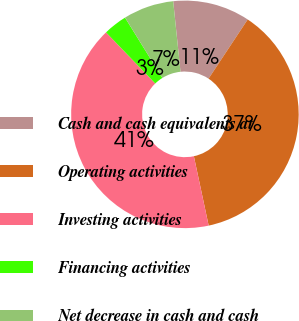Convert chart. <chart><loc_0><loc_0><loc_500><loc_500><pie_chart><fcel>Cash and cash equivalents at<fcel>Operating activities<fcel>Investing activities<fcel>Financing activities<fcel>Net decrease in cash and cash<nl><fcel>10.95%<fcel>37.35%<fcel>41.16%<fcel>3.37%<fcel>7.18%<nl></chart> 